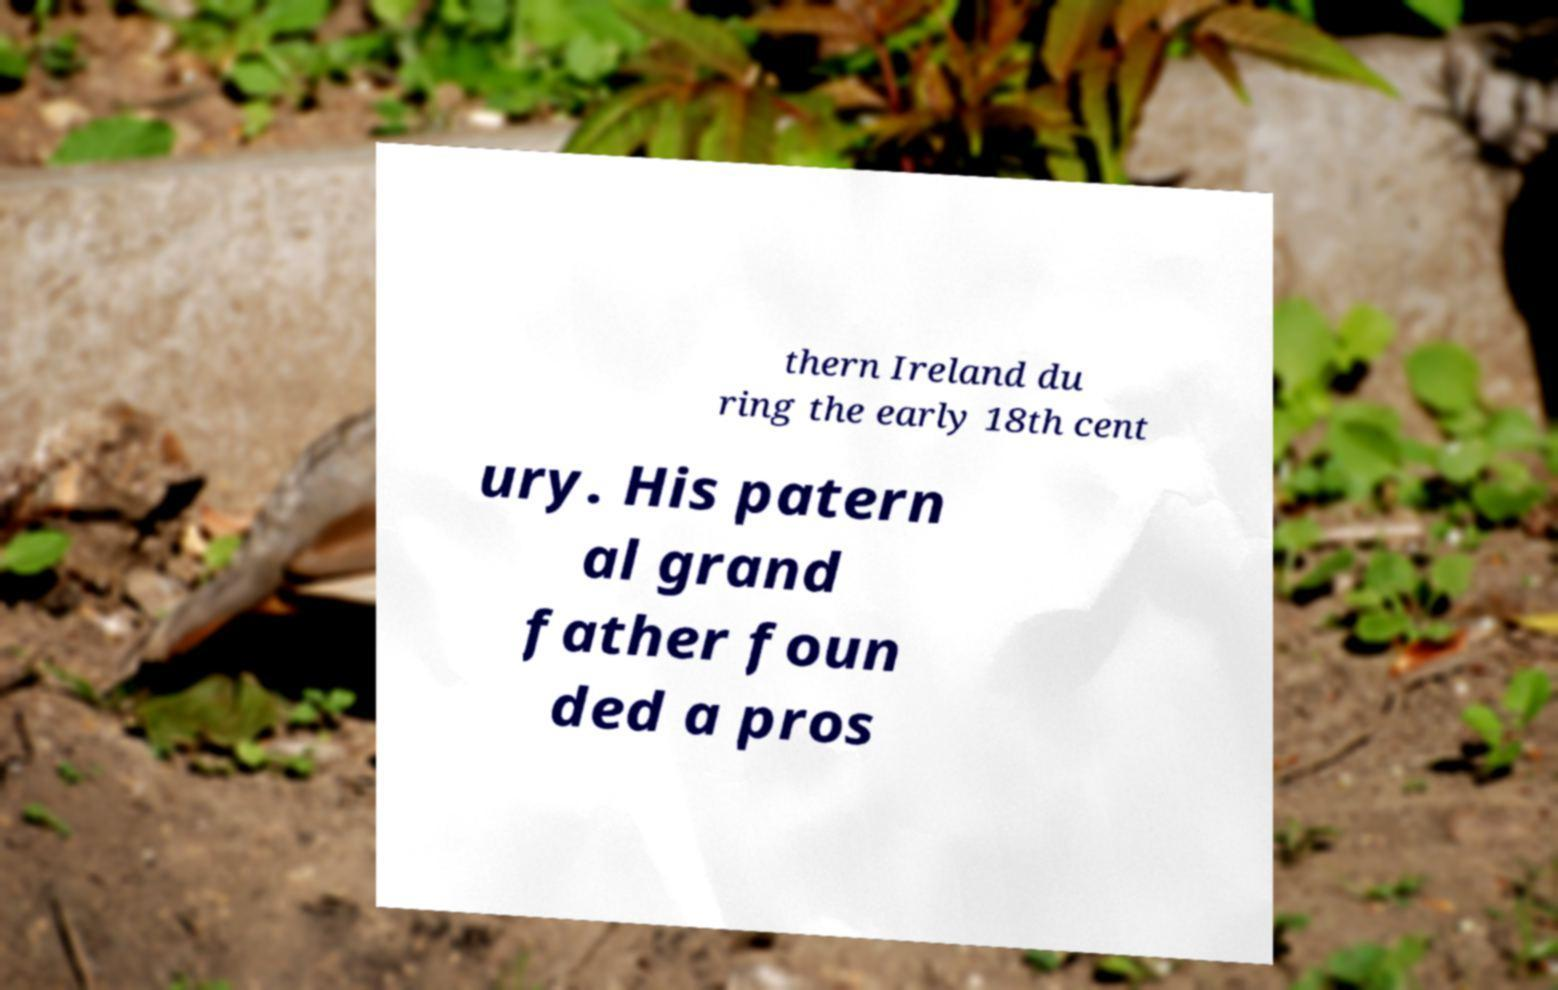Could you assist in decoding the text presented in this image and type it out clearly? thern Ireland du ring the early 18th cent ury. His patern al grand father foun ded a pros 